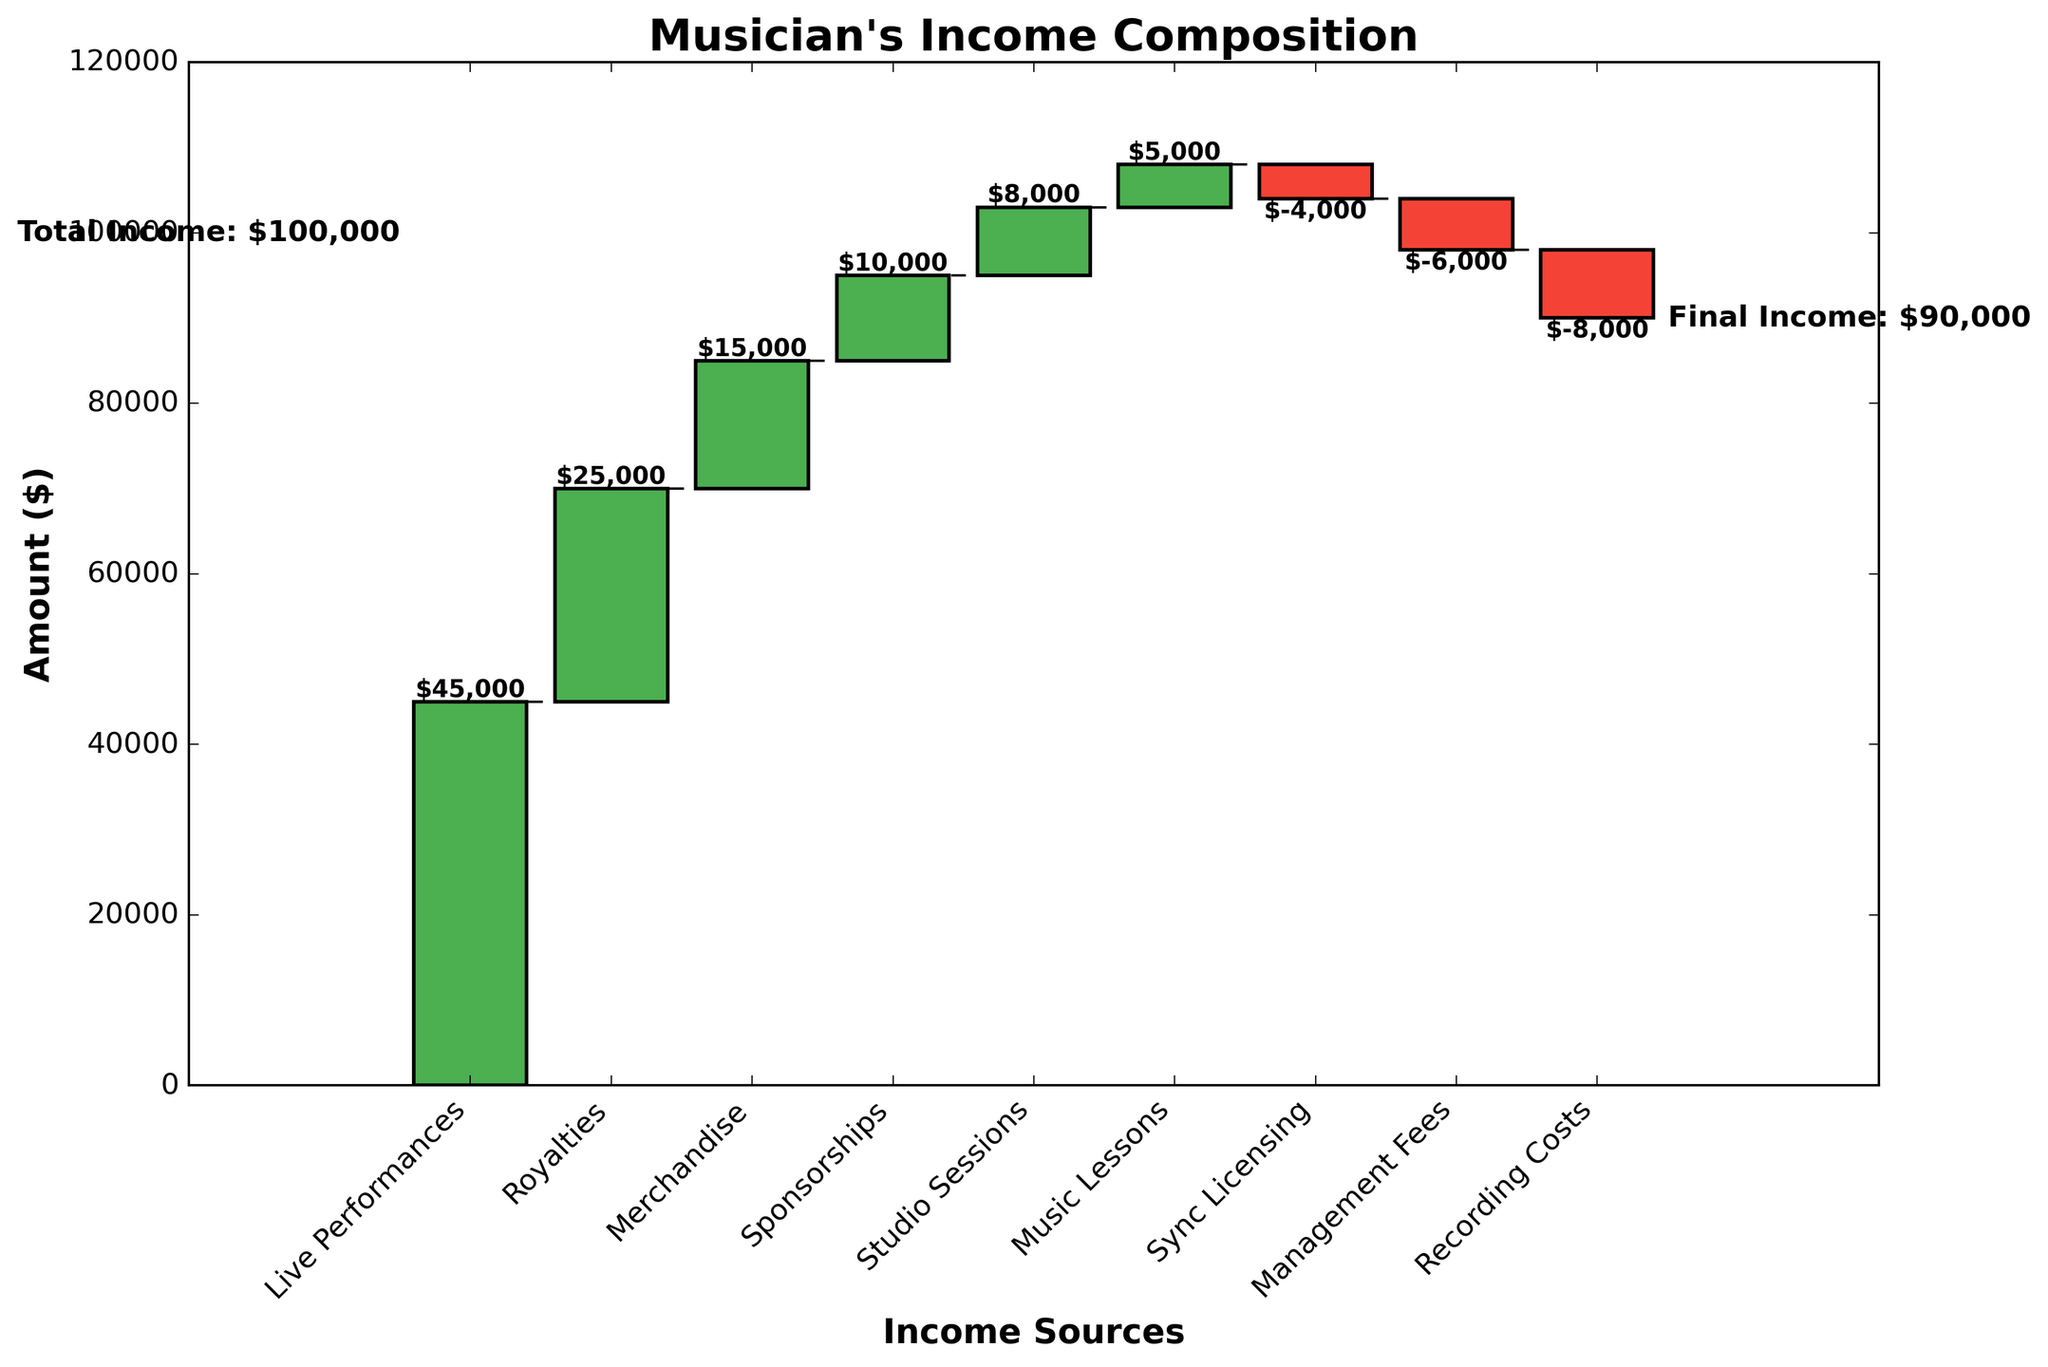What's the title of the chart? The title of the chart is displayed at the top of the figure. It reads "Musician's Income Composition."
Answer: Musician's Income Composition How much does the musician earn from live performances? The figure shows a bar with the label "Live Performances" and a value next to it. The value shown is $45,000.
Answer: $45,000 What is the category with the highest positive value? The bars in green represent positive values. Among these, the category with the highest value is "Live Performances" with $45,000.
Answer: Live Performances What's the total contribution of negative values in the chart? Sum the negative values: Sync Licensing (-$4,000), Management Fees (-$6,000), and Recording Costs (-$8,000). -4000 - 6000 - 8000 = -18000.
Answer: -$18,000 How much more does the musician earn from royalties compared to sponsorships? Refer to the values: Royalties ($25,000) and Sponsorships ($10,000). Subtract the value for Sponsorships from Royalties: 25,000 - 10,000 = $15,000.
Answer: $15,000 Which income source contributes $8,000, and what's its significance? The figure shows bars with values next to them. The category "Studio Sessions" has a value of $8,000.
Answer: Studio Sessions Is the final income higher or lower than the total income? Compare the values: Total Income is $100,000 and Final Income is $90,000. Since 90,000 is less than 100,000, the final income is lower.
Answer: Lower Which category incurs the highest cost? The red bars represent costs. The category with the highest negative value is "Recording Costs" with -$8,000.
Answer: Recording Costs What's the combined income from live performances and merchandise? Add the values of Live Performances ($45,000) and Merchandise ($15,000): 45,000 + 15,000 = $60,000.
Answer: $60,000 What’s the effect of sync licensing on the musician's income? Sync Licensing has a negative value of -$4,000. This means it decreases the musician's income by $4,000.
Answer: Decreases by $4,000 